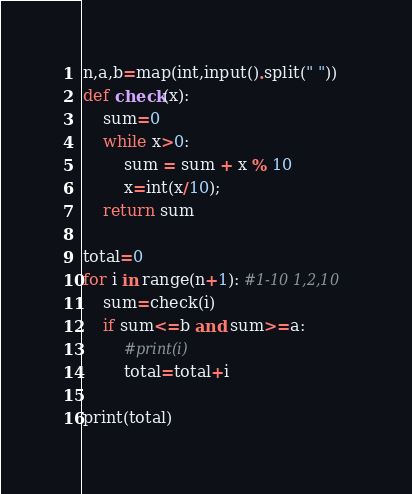<code> <loc_0><loc_0><loc_500><loc_500><_Python_>n,a,b=map(int,input().split(" "))
def check(x):
    sum=0
    while x>0: 
        sum = sum + x % 10 
        x=int(x/10); 
    return sum
 
total=0
for i in range(n+1): #1-10 1,2,10
    sum=check(i)
    if sum<=b and sum>=a:
        #print(i)
        total=total+i

print(total)</code> 